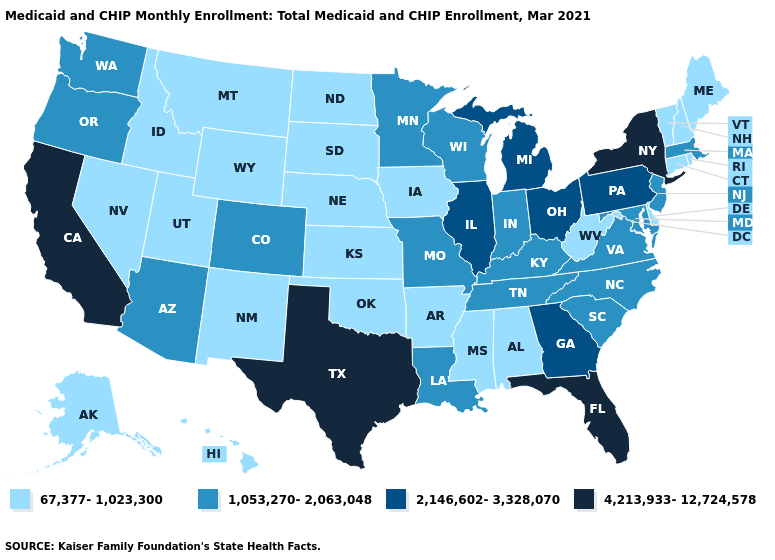Among the states that border North Carolina , which have the highest value?
Give a very brief answer. Georgia. Among the states that border Florida , which have the highest value?
Quick response, please. Georgia. Name the states that have a value in the range 4,213,933-12,724,578?
Write a very short answer. California, Florida, New York, Texas. Does Louisiana have the highest value in the USA?
Short answer required. No. Among the states that border Montana , which have the lowest value?
Concise answer only. Idaho, North Dakota, South Dakota, Wyoming. What is the value of Massachusetts?
Quick response, please. 1,053,270-2,063,048. Name the states that have a value in the range 1,053,270-2,063,048?
Quick response, please. Arizona, Colorado, Indiana, Kentucky, Louisiana, Maryland, Massachusetts, Minnesota, Missouri, New Jersey, North Carolina, Oregon, South Carolina, Tennessee, Virginia, Washington, Wisconsin. Does Kentucky have the lowest value in the USA?
Quick response, please. No. Name the states that have a value in the range 4,213,933-12,724,578?
Concise answer only. California, Florida, New York, Texas. Does the map have missing data?
Concise answer only. No. Is the legend a continuous bar?
Concise answer only. No. Name the states that have a value in the range 1,053,270-2,063,048?
Answer briefly. Arizona, Colorado, Indiana, Kentucky, Louisiana, Maryland, Massachusetts, Minnesota, Missouri, New Jersey, North Carolina, Oregon, South Carolina, Tennessee, Virginia, Washington, Wisconsin. Does Delaware have a lower value than New Hampshire?
Be succinct. No. What is the value of Virginia?
Keep it brief. 1,053,270-2,063,048. What is the value of Hawaii?
Be succinct. 67,377-1,023,300. 